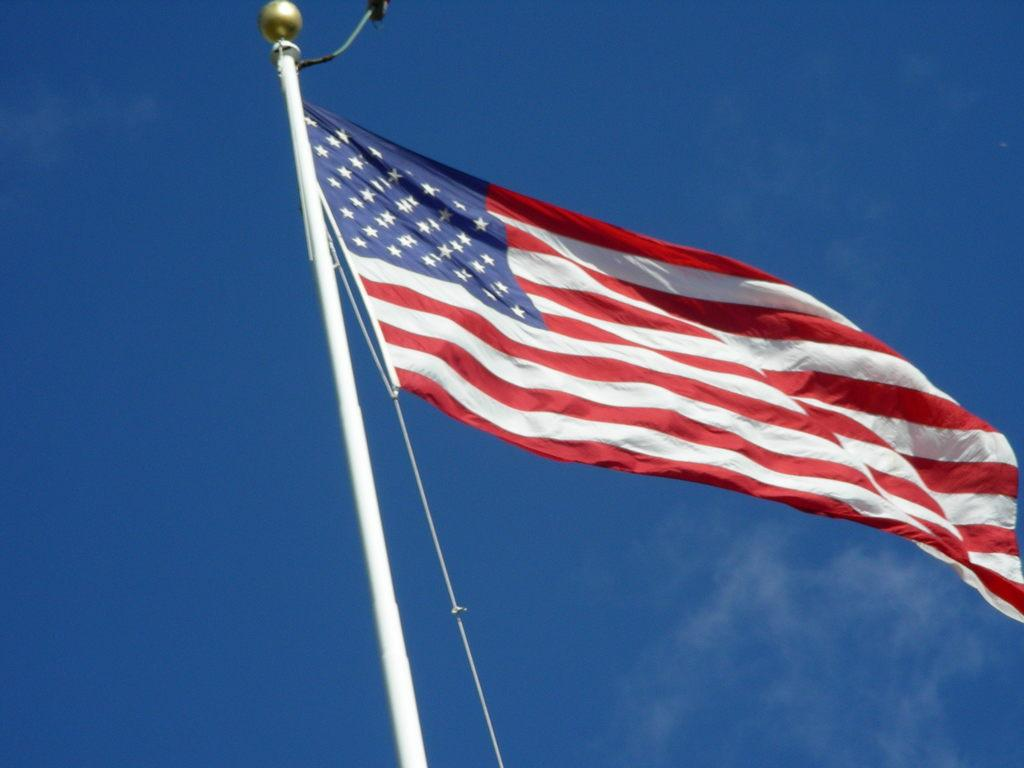What object is present in the image that represents a country or organization? There is a flag in the image. How is the flag displayed in the image? The flag is on a pole. What colors can be seen on the flag in the image? The flag has red, white, and blue colors. What is visible at the top of the image? The sky is visible at the top of the image. Can you tell me how many hills are visible in the image? There are no hills visible in the image; it only features a flag on a pole. What type of calendar is shown hanging on the flagpole in the image? There is no calendar present in the image; it only features a flag on a pole. 